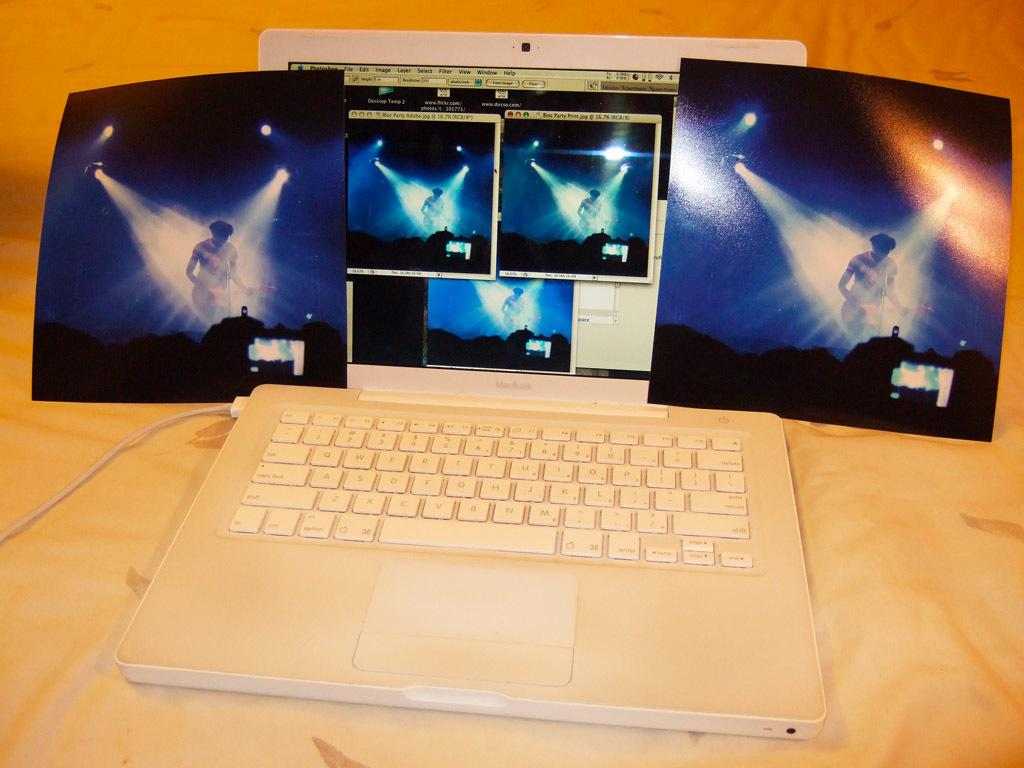<image>
Write a terse but informative summary of the picture. White Macbook showing a photo of a performer on the screen. 